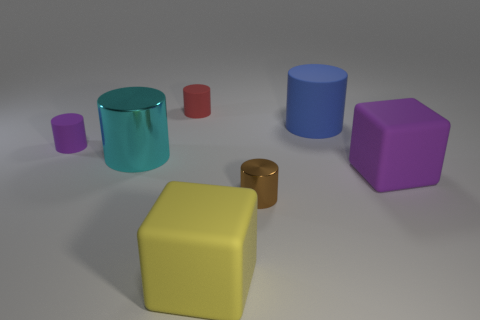Is there anything else that has the same size as the red object?
Make the answer very short. Yes. There is another rubber cylinder that is the same size as the red cylinder; what is its color?
Ensure brevity in your answer.  Purple. What number of other things are the same shape as the red object?
Offer a terse response. 4. Do the yellow thing and the red cylinder have the same size?
Your answer should be compact. No. Is the number of yellow rubber objects right of the brown object greater than the number of matte cylinders that are right of the cyan thing?
Provide a succinct answer. No. How many other objects are there of the same size as the yellow thing?
Your answer should be compact. 3. Are there more large rubber cylinders that are behind the purple rubber cube than red things?
Your response must be concise. No. The purple thing that is on the right side of the shiny cylinder that is on the left side of the large yellow thing is what shape?
Give a very brief answer. Cube. Is the number of yellow rubber things greater than the number of big red blocks?
Give a very brief answer. Yes. What number of purple things are both behind the big metallic object and right of the big yellow object?
Offer a very short reply. 0. 